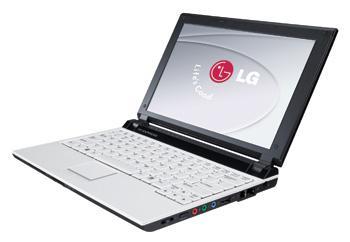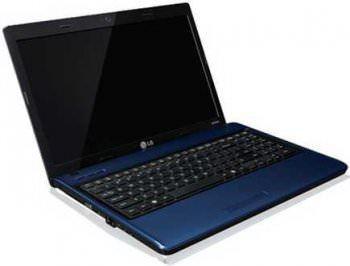The first image is the image on the left, the second image is the image on the right. Analyze the images presented: Is the assertion "At least one of the laptops has a blank screen." valid? Answer yes or no. Yes. The first image is the image on the left, the second image is the image on the right. Analyze the images presented: Is the assertion "Each image contains exactly one open laptop, at least one image contains a laptop with something displayed on its screen, and the laptops on the left and right face different directions." valid? Answer yes or no. Yes. 